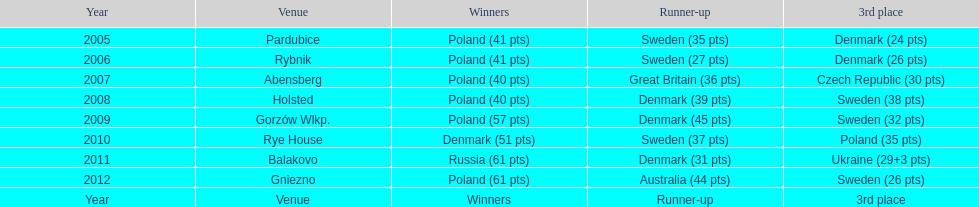Parse the table in full. {'header': ['Year', 'Venue', 'Winners', 'Runner-up', '3rd place'], 'rows': [['2005', 'Pardubice', 'Poland (41 pts)', 'Sweden (35 pts)', 'Denmark (24 pts)'], ['2006', 'Rybnik', 'Poland (41 pts)', 'Sweden (27 pts)', 'Denmark (26 pts)'], ['2007', 'Abensberg', 'Poland (40 pts)', 'Great Britain (36 pts)', 'Czech Republic (30 pts)'], ['2008', 'Holsted', 'Poland (40 pts)', 'Denmark (39 pts)', 'Sweden (38 pts)'], ['2009', 'Gorzów Wlkp.', 'Poland (57 pts)', 'Denmark (45 pts)', 'Sweden (32 pts)'], ['2010', 'Rye House', 'Denmark (51 pts)', 'Sweden (37 pts)', 'Poland (35 pts)'], ['2011', 'Balakovo', 'Russia (61 pts)', 'Denmark (31 pts)', 'Ukraine (29+3 pts)'], ['2012', 'Gniezno', 'Poland (61 pts)', 'Australia (44 pts)', 'Sweden (26 pts)'], ['Year', 'Venue', 'Winners', 'Runner-up', '3rd place']]} Before 2008, how many times was sweden the second-place finisher? 2. 